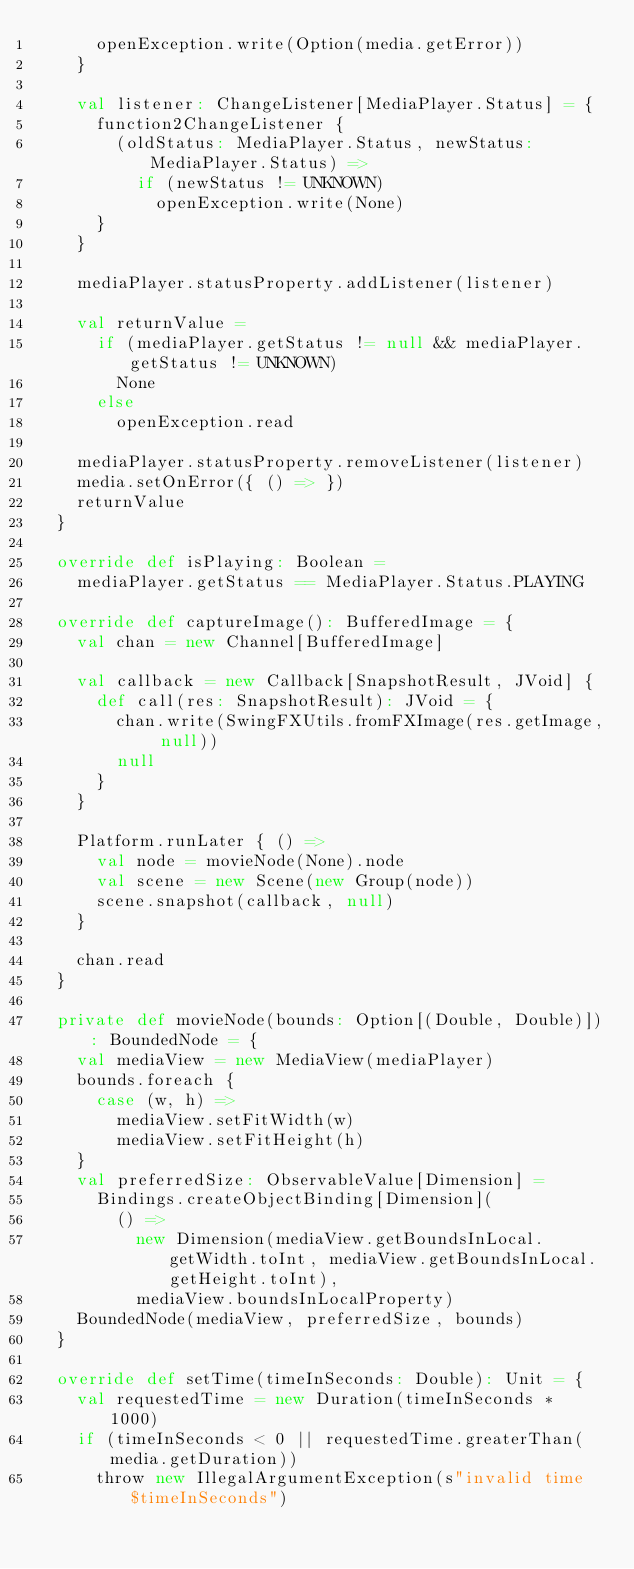<code> <loc_0><loc_0><loc_500><loc_500><_Scala_>      openException.write(Option(media.getError))
    }

    val listener: ChangeListener[MediaPlayer.Status] = {
      function2ChangeListener {
        (oldStatus: MediaPlayer.Status, newStatus: MediaPlayer.Status) =>
          if (newStatus != UNKNOWN)
            openException.write(None)
      }
    }

    mediaPlayer.statusProperty.addListener(listener)

    val returnValue =
      if (mediaPlayer.getStatus != null && mediaPlayer.getStatus != UNKNOWN)
        None
      else
        openException.read

    mediaPlayer.statusProperty.removeListener(listener)
    media.setOnError({ () => })
    returnValue
  }

  override def isPlaying: Boolean =
    mediaPlayer.getStatus == MediaPlayer.Status.PLAYING

  override def captureImage(): BufferedImage = {
    val chan = new Channel[BufferedImage]

    val callback = new Callback[SnapshotResult, JVoid] {
      def call(res: SnapshotResult): JVoid = {
        chan.write(SwingFXUtils.fromFXImage(res.getImage, null))
        null
      }
    }

    Platform.runLater { () =>
      val node = movieNode(None).node
      val scene = new Scene(new Group(node))
      scene.snapshot(callback, null)
    }

    chan.read
  }

  private def movieNode(bounds: Option[(Double, Double)]): BoundedNode = {
    val mediaView = new MediaView(mediaPlayer)
    bounds.foreach {
      case (w, h) =>
        mediaView.setFitWidth(w)
        mediaView.setFitHeight(h)
    }
    val preferredSize: ObservableValue[Dimension] =
      Bindings.createObjectBinding[Dimension](
        () =>
          new Dimension(mediaView.getBoundsInLocal.getWidth.toInt, mediaView.getBoundsInLocal.getHeight.toInt),
          mediaView.boundsInLocalProperty)
    BoundedNode(mediaView, preferredSize, bounds)
  }

  override def setTime(timeInSeconds: Double): Unit = {
    val requestedTime = new Duration(timeInSeconds * 1000)
    if (timeInSeconds < 0 || requestedTime.greaterThan(media.getDuration))
      throw new IllegalArgumentException(s"invalid time $timeInSeconds")</code> 